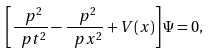<formula> <loc_0><loc_0><loc_500><loc_500>\left [ \frac { \ p ^ { 2 } } { \ p t ^ { 2 } } - \frac { \ p ^ { 2 } } { \ p x ^ { 2 } } + V ( x ) \right ] \Psi = 0 ,</formula> 